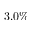<formula> <loc_0><loc_0><loc_500><loc_500>3 . 0 \%</formula> 